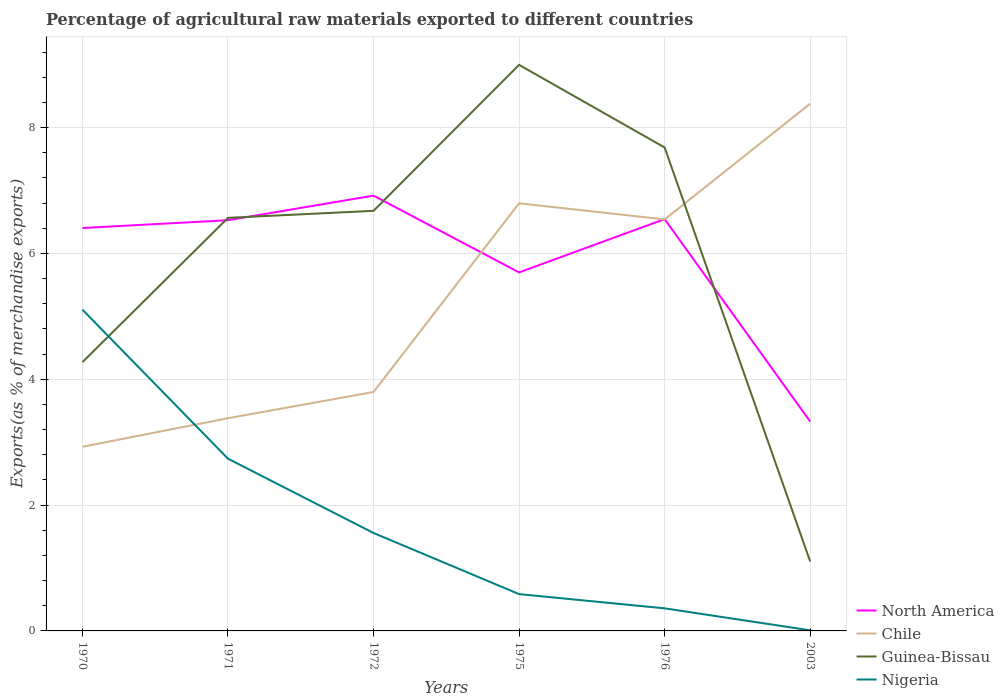Does the line corresponding to Guinea-Bissau intersect with the line corresponding to Nigeria?
Your answer should be very brief. Yes. Is the number of lines equal to the number of legend labels?
Keep it short and to the point. Yes. Across all years, what is the maximum percentage of exports to different countries in Chile?
Provide a succinct answer. 2.93. In which year was the percentage of exports to different countries in Nigeria maximum?
Give a very brief answer. 2003. What is the total percentage of exports to different countries in North America in the graph?
Provide a short and direct response. 3.59. What is the difference between the highest and the second highest percentage of exports to different countries in Nigeria?
Provide a short and direct response. 5.1. What is the difference between the highest and the lowest percentage of exports to different countries in Chile?
Offer a terse response. 3. Is the percentage of exports to different countries in Guinea-Bissau strictly greater than the percentage of exports to different countries in Chile over the years?
Keep it short and to the point. No. How many lines are there?
Your answer should be compact. 4. Are the values on the major ticks of Y-axis written in scientific E-notation?
Provide a short and direct response. No. Does the graph contain grids?
Offer a terse response. Yes. How many legend labels are there?
Ensure brevity in your answer.  4. What is the title of the graph?
Your answer should be compact. Percentage of agricultural raw materials exported to different countries. Does "Heavily indebted poor countries" appear as one of the legend labels in the graph?
Keep it short and to the point. No. What is the label or title of the Y-axis?
Ensure brevity in your answer.  Exports(as % of merchandise exports). What is the Exports(as % of merchandise exports) in North America in 1970?
Provide a short and direct response. 6.4. What is the Exports(as % of merchandise exports) of Chile in 1970?
Offer a terse response. 2.93. What is the Exports(as % of merchandise exports) of Guinea-Bissau in 1970?
Make the answer very short. 4.27. What is the Exports(as % of merchandise exports) in Nigeria in 1970?
Your response must be concise. 5.11. What is the Exports(as % of merchandise exports) of North America in 1971?
Your response must be concise. 6.53. What is the Exports(as % of merchandise exports) in Chile in 1971?
Make the answer very short. 3.38. What is the Exports(as % of merchandise exports) in Guinea-Bissau in 1971?
Your answer should be compact. 6.57. What is the Exports(as % of merchandise exports) in Nigeria in 1971?
Provide a succinct answer. 2.74. What is the Exports(as % of merchandise exports) of North America in 1972?
Provide a short and direct response. 6.92. What is the Exports(as % of merchandise exports) in Chile in 1972?
Make the answer very short. 3.8. What is the Exports(as % of merchandise exports) of Guinea-Bissau in 1972?
Your answer should be compact. 6.68. What is the Exports(as % of merchandise exports) in Nigeria in 1972?
Offer a very short reply. 1.56. What is the Exports(as % of merchandise exports) in North America in 1975?
Your answer should be compact. 5.7. What is the Exports(as % of merchandise exports) of Chile in 1975?
Your answer should be very brief. 6.8. What is the Exports(as % of merchandise exports) in Guinea-Bissau in 1975?
Make the answer very short. 9. What is the Exports(as % of merchandise exports) in Nigeria in 1975?
Ensure brevity in your answer.  0.59. What is the Exports(as % of merchandise exports) in North America in 1976?
Your response must be concise. 6.55. What is the Exports(as % of merchandise exports) in Chile in 1976?
Make the answer very short. 6.54. What is the Exports(as % of merchandise exports) in Guinea-Bissau in 1976?
Offer a very short reply. 7.68. What is the Exports(as % of merchandise exports) in Nigeria in 1976?
Make the answer very short. 0.36. What is the Exports(as % of merchandise exports) in North America in 2003?
Offer a very short reply. 3.33. What is the Exports(as % of merchandise exports) of Chile in 2003?
Provide a succinct answer. 8.38. What is the Exports(as % of merchandise exports) in Guinea-Bissau in 2003?
Your answer should be very brief. 1.1. What is the Exports(as % of merchandise exports) of Nigeria in 2003?
Give a very brief answer. 0.01. Across all years, what is the maximum Exports(as % of merchandise exports) of North America?
Ensure brevity in your answer.  6.92. Across all years, what is the maximum Exports(as % of merchandise exports) in Chile?
Offer a very short reply. 8.38. Across all years, what is the maximum Exports(as % of merchandise exports) of Guinea-Bissau?
Your answer should be very brief. 9. Across all years, what is the maximum Exports(as % of merchandise exports) in Nigeria?
Your response must be concise. 5.11. Across all years, what is the minimum Exports(as % of merchandise exports) of North America?
Offer a terse response. 3.33. Across all years, what is the minimum Exports(as % of merchandise exports) of Chile?
Your answer should be very brief. 2.93. Across all years, what is the minimum Exports(as % of merchandise exports) in Guinea-Bissau?
Your answer should be compact. 1.1. Across all years, what is the minimum Exports(as % of merchandise exports) of Nigeria?
Offer a very short reply. 0.01. What is the total Exports(as % of merchandise exports) of North America in the graph?
Your response must be concise. 35.43. What is the total Exports(as % of merchandise exports) in Chile in the graph?
Your response must be concise. 31.83. What is the total Exports(as % of merchandise exports) in Guinea-Bissau in the graph?
Provide a succinct answer. 35.3. What is the total Exports(as % of merchandise exports) in Nigeria in the graph?
Your answer should be compact. 10.36. What is the difference between the Exports(as % of merchandise exports) in North America in 1970 and that in 1971?
Provide a short and direct response. -0.12. What is the difference between the Exports(as % of merchandise exports) of Chile in 1970 and that in 1971?
Offer a terse response. -0.45. What is the difference between the Exports(as % of merchandise exports) of Guinea-Bissau in 1970 and that in 1971?
Keep it short and to the point. -2.29. What is the difference between the Exports(as % of merchandise exports) of Nigeria in 1970 and that in 1971?
Provide a succinct answer. 2.37. What is the difference between the Exports(as % of merchandise exports) of North America in 1970 and that in 1972?
Offer a terse response. -0.52. What is the difference between the Exports(as % of merchandise exports) in Chile in 1970 and that in 1972?
Give a very brief answer. -0.87. What is the difference between the Exports(as % of merchandise exports) in Guinea-Bissau in 1970 and that in 1972?
Your answer should be very brief. -2.41. What is the difference between the Exports(as % of merchandise exports) in Nigeria in 1970 and that in 1972?
Give a very brief answer. 3.55. What is the difference between the Exports(as % of merchandise exports) in North America in 1970 and that in 1975?
Provide a succinct answer. 0.71. What is the difference between the Exports(as % of merchandise exports) of Chile in 1970 and that in 1975?
Provide a succinct answer. -3.87. What is the difference between the Exports(as % of merchandise exports) in Guinea-Bissau in 1970 and that in 1975?
Keep it short and to the point. -4.73. What is the difference between the Exports(as % of merchandise exports) in Nigeria in 1970 and that in 1975?
Your answer should be very brief. 4.52. What is the difference between the Exports(as % of merchandise exports) in North America in 1970 and that in 1976?
Provide a short and direct response. -0.14. What is the difference between the Exports(as % of merchandise exports) in Chile in 1970 and that in 1976?
Your answer should be compact. -3.61. What is the difference between the Exports(as % of merchandise exports) of Guinea-Bissau in 1970 and that in 1976?
Your response must be concise. -3.41. What is the difference between the Exports(as % of merchandise exports) of Nigeria in 1970 and that in 1976?
Offer a terse response. 4.75. What is the difference between the Exports(as % of merchandise exports) in North America in 1970 and that in 2003?
Provide a short and direct response. 3.08. What is the difference between the Exports(as % of merchandise exports) of Chile in 1970 and that in 2003?
Your response must be concise. -5.45. What is the difference between the Exports(as % of merchandise exports) in Guinea-Bissau in 1970 and that in 2003?
Offer a terse response. 3.17. What is the difference between the Exports(as % of merchandise exports) in Nigeria in 1970 and that in 2003?
Ensure brevity in your answer.  5.1. What is the difference between the Exports(as % of merchandise exports) in North America in 1971 and that in 1972?
Give a very brief answer. -0.39. What is the difference between the Exports(as % of merchandise exports) of Chile in 1971 and that in 1972?
Provide a succinct answer. -0.42. What is the difference between the Exports(as % of merchandise exports) of Guinea-Bissau in 1971 and that in 1972?
Offer a terse response. -0.11. What is the difference between the Exports(as % of merchandise exports) of Nigeria in 1971 and that in 1972?
Ensure brevity in your answer.  1.18. What is the difference between the Exports(as % of merchandise exports) of North America in 1971 and that in 1975?
Offer a very short reply. 0.83. What is the difference between the Exports(as % of merchandise exports) in Chile in 1971 and that in 1975?
Offer a terse response. -3.42. What is the difference between the Exports(as % of merchandise exports) of Guinea-Bissau in 1971 and that in 1975?
Give a very brief answer. -2.43. What is the difference between the Exports(as % of merchandise exports) in Nigeria in 1971 and that in 1975?
Provide a succinct answer. 2.15. What is the difference between the Exports(as % of merchandise exports) of North America in 1971 and that in 1976?
Offer a very short reply. -0.02. What is the difference between the Exports(as % of merchandise exports) in Chile in 1971 and that in 1976?
Provide a succinct answer. -3.16. What is the difference between the Exports(as % of merchandise exports) of Guinea-Bissau in 1971 and that in 1976?
Ensure brevity in your answer.  -1.12. What is the difference between the Exports(as % of merchandise exports) in Nigeria in 1971 and that in 1976?
Ensure brevity in your answer.  2.38. What is the difference between the Exports(as % of merchandise exports) of Chile in 1971 and that in 2003?
Provide a succinct answer. -5. What is the difference between the Exports(as % of merchandise exports) in Guinea-Bissau in 1971 and that in 2003?
Your response must be concise. 5.46. What is the difference between the Exports(as % of merchandise exports) of Nigeria in 1971 and that in 2003?
Your response must be concise. 2.73. What is the difference between the Exports(as % of merchandise exports) of North America in 1972 and that in 1975?
Keep it short and to the point. 1.22. What is the difference between the Exports(as % of merchandise exports) of Chile in 1972 and that in 1975?
Ensure brevity in your answer.  -3. What is the difference between the Exports(as % of merchandise exports) in Guinea-Bissau in 1972 and that in 1975?
Give a very brief answer. -2.32. What is the difference between the Exports(as % of merchandise exports) in Nigeria in 1972 and that in 1975?
Offer a very short reply. 0.97. What is the difference between the Exports(as % of merchandise exports) of North America in 1972 and that in 1976?
Your answer should be very brief. 0.37. What is the difference between the Exports(as % of merchandise exports) of Chile in 1972 and that in 1976?
Offer a very short reply. -2.74. What is the difference between the Exports(as % of merchandise exports) of Guinea-Bissau in 1972 and that in 1976?
Provide a short and direct response. -1.01. What is the difference between the Exports(as % of merchandise exports) of Nigeria in 1972 and that in 1976?
Provide a short and direct response. 1.2. What is the difference between the Exports(as % of merchandise exports) in North America in 1972 and that in 2003?
Make the answer very short. 3.59. What is the difference between the Exports(as % of merchandise exports) of Chile in 1972 and that in 2003?
Give a very brief answer. -4.58. What is the difference between the Exports(as % of merchandise exports) of Guinea-Bissau in 1972 and that in 2003?
Your answer should be compact. 5.57. What is the difference between the Exports(as % of merchandise exports) of Nigeria in 1972 and that in 2003?
Offer a terse response. 1.55. What is the difference between the Exports(as % of merchandise exports) in North America in 1975 and that in 1976?
Your response must be concise. -0.85. What is the difference between the Exports(as % of merchandise exports) in Chile in 1975 and that in 1976?
Offer a very short reply. 0.26. What is the difference between the Exports(as % of merchandise exports) in Guinea-Bissau in 1975 and that in 1976?
Give a very brief answer. 1.31. What is the difference between the Exports(as % of merchandise exports) in Nigeria in 1975 and that in 1976?
Offer a terse response. 0.23. What is the difference between the Exports(as % of merchandise exports) of North America in 1975 and that in 2003?
Provide a succinct answer. 2.37. What is the difference between the Exports(as % of merchandise exports) in Chile in 1975 and that in 2003?
Offer a very short reply. -1.58. What is the difference between the Exports(as % of merchandise exports) of Guinea-Bissau in 1975 and that in 2003?
Your response must be concise. 7.89. What is the difference between the Exports(as % of merchandise exports) of Nigeria in 1975 and that in 2003?
Offer a very short reply. 0.58. What is the difference between the Exports(as % of merchandise exports) in North America in 1976 and that in 2003?
Your response must be concise. 3.22. What is the difference between the Exports(as % of merchandise exports) of Chile in 1976 and that in 2003?
Your answer should be compact. -1.84. What is the difference between the Exports(as % of merchandise exports) of Guinea-Bissau in 1976 and that in 2003?
Provide a succinct answer. 6.58. What is the difference between the Exports(as % of merchandise exports) in Nigeria in 1976 and that in 2003?
Make the answer very short. 0.35. What is the difference between the Exports(as % of merchandise exports) of North America in 1970 and the Exports(as % of merchandise exports) of Chile in 1971?
Keep it short and to the point. 3.02. What is the difference between the Exports(as % of merchandise exports) of North America in 1970 and the Exports(as % of merchandise exports) of Guinea-Bissau in 1971?
Your response must be concise. -0.16. What is the difference between the Exports(as % of merchandise exports) in North America in 1970 and the Exports(as % of merchandise exports) in Nigeria in 1971?
Provide a succinct answer. 3.67. What is the difference between the Exports(as % of merchandise exports) in Chile in 1970 and the Exports(as % of merchandise exports) in Guinea-Bissau in 1971?
Give a very brief answer. -3.64. What is the difference between the Exports(as % of merchandise exports) of Chile in 1970 and the Exports(as % of merchandise exports) of Nigeria in 1971?
Make the answer very short. 0.19. What is the difference between the Exports(as % of merchandise exports) of Guinea-Bissau in 1970 and the Exports(as % of merchandise exports) of Nigeria in 1971?
Offer a terse response. 1.53. What is the difference between the Exports(as % of merchandise exports) of North America in 1970 and the Exports(as % of merchandise exports) of Chile in 1972?
Offer a terse response. 2.61. What is the difference between the Exports(as % of merchandise exports) in North America in 1970 and the Exports(as % of merchandise exports) in Guinea-Bissau in 1972?
Give a very brief answer. -0.27. What is the difference between the Exports(as % of merchandise exports) in North America in 1970 and the Exports(as % of merchandise exports) in Nigeria in 1972?
Your response must be concise. 4.85. What is the difference between the Exports(as % of merchandise exports) of Chile in 1970 and the Exports(as % of merchandise exports) of Guinea-Bissau in 1972?
Make the answer very short. -3.75. What is the difference between the Exports(as % of merchandise exports) of Chile in 1970 and the Exports(as % of merchandise exports) of Nigeria in 1972?
Make the answer very short. 1.37. What is the difference between the Exports(as % of merchandise exports) of Guinea-Bissau in 1970 and the Exports(as % of merchandise exports) of Nigeria in 1972?
Give a very brief answer. 2.71. What is the difference between the Exports(as % of merchandise exports) in North America in 1970 and the Exports(as % of merchandise exports) in Chile in 1975?
Make the answer very short. -0.39. What is the difference between the Exports(as % of merchandise exports) in North America in 1970 and the Exports(as % of merchandise exports) in Guinea-Bissau in 1975?
Ensure brevity in your answer.  -2.59. What is the difference between the Exports(as % of merchandise exports) in North America in 1970 and the Exports(as % of merchandise exports) in Nigeria in 1975?
Provide a succinct answer. 5.82. What is the difference between the Exports(as % of merchandise exports) in Chile in 1970 and the Exports(as % of merchandise exports) in Guinea-Bissau in 1975?
Keep it short and to the point. -6.07. What is the difference between the Exports(as % of merchandise exports) in Chile in 1970 and the Exports(as % of merchandise exports) in Nigeria in 1975?
Your response must be concise. 2.34. What is the difference between the Exports(as % of merchandise exports) in Guinea-Bissau in 1970 and the Exports(as % of merchandise exports) in Nigeria in 1975?
Your response must be concise. 3.69. What is the difference between the Exports(as % of merchandise exports) of North America in 1970 and the Exports(as % of merchandise exports) of Chile in 1976?
Make the answer very short. -0.14. What is the difference between the Exports(as % of merchandise exports) of North America in 1970 and the Exports(as % of merchandise exports) of Guinea-Bissau in 1976?
Offer a very short reply. -1.28. What is the difference between the Exports(as % of merchandise exports) in North America in 1970 and the Exports(as % of merchandise exports) in Nigeria in 1976?
Your answer should be very brief. 6.05. What is the difference between the Exports(as % of merchandise exports) of Chile in 1970 and the Exports(as % of merchandise exports) of Guinea-Bissau in 1976?
Ensure brevity in your answer.  -4.76. What is the difference between the Exports(as % of merchandise exports) of Chile in 1970 and the Exports(as % of merchandise exports) of Nigeria in 1976?
Make the answer very short. 2.57. What is the difference between the Exports(as % of merchandise exports) of Guinea-Bissau in 1970 and the Exports(as % of merchandise exports) of Nigeria in 1976?
Offer a very short reply. 3.91. What is the difference between the Exports(as % of merchandise exports) of North America in 1970 and the Exports(as % of merchandise exports) of Chile in 2003?
Keep it short and to the point. -1.98. What is the difference between the Exports(as % of merchandise exports) of North America in 1970 and the Exports(as % of merchandise exports) of Guinea-Bissau in 2003?
Make the answer very short. 5.3. What is the difference between the Exports(as % of merchandise exports) in North America in 1970 and the Exports(as % of merchandise exports) in Nigeria in 2003?
Provide a short and direct response. 6.4. What is the difference between the Exports(as % of merchandise exports) of Chile in 1970 and the Exports(as % of merchandise exports) of Guinea-Bissau in 2003?
Offer a terse response. 1.82. What is the difference between the Exports(as % of merchandise exports) in Chile in 1970 and the Exports(as % of merchandise exports) in Nigeria in 2003?
Make the answer very short. 2.92. What is the difference between the Exports(as % of merchandise exports) of Guinea-Bissau in 1970 and the Exports(as % of merchandise exports) of Nigeria in 2003?
Your answer should be compact. 4.26. What is the difference between the Exports(as % of merchandise exports) of North America in 1971 and the Exports(as % of merchandise exports) of Chile in 1972?
Provide a short and direct response. 2.73. What is the difference between the Exports(as % of merchandise exports) of North America in 1971 and the Exports(as % of merchandise exports) of Guinea-Bissau in 1972?
Provide a succinct answer. -0.15. What is the difference between the Exports(as % of merchandise exports) of North America in 1971 and the Exports(as % of merchandise exports) of Nigeria in 1972?
Provide a succinct answer. 4.97. What is the difference between the Exports(as % of merchandise exports) in Chile in 1971 and the Exports(as % of merchandise exports) in Guinea-Bissau in 1972?
Give a very brief answer. -3.3. What is the difference between the Exports(as % of merchandise exports) in Chile in 1971 and the Exports(as % of merchandise exports) in Nigeria in 1972?
Provide a succinct answer. 1.82. What is the difference between the Exports(as % of merchandise exports) of Guinea-Bissau in 1971 and the Exports(as % of merchandise exports) of Nigeria in 1972?
Keep it short and to the point. 5.01. What is the difference between the Exports(as % of merchandise exports) of North America in 1971 and the Exports(as % of merchandise exports) of Chile in 1975?
Your answer should be compact. -0.27. What is the difference between the Exports(as % of merchandise exports) in North America in 1971 and the Exports(as % of merchandise exports) in Guinea-Bissau in 1975?
Keep it short and to the point. -2.47. What is the difference between the Exports(as % of merchandise exports) of North America in 1971 and the Exports(as % of merchandise exports) of Nigeria in 1975?
Provide a short and direct response. 5.94. What is the difference between the Exports(as % of merchandise exports) in Chile in 1971 and the Exports(as % of merchandise exports) in Guinea-Bissau in 1975?
Your response must be concise. -5.62. What is the difference between the Exports(as % of merchandise exports) of Chile in 1971 and the Exports(as % of merchandise exports) of Nigeria in 1975?
Your response must be concise. 2.8. What is the difference between the Exports(as % of merchandise exports) in Guinea-Bissau in 1971 and the Exports(as % of merchandise exports) in Nigeria in 1975?
Keep it short and to the point. 5.98. What is the difference between the Exports(as % of merchandise exports) in North America in 1971 and the Exports(as % of merchandise exports) in Chile in 1976?
Your answer should be compact. -0.01. What is the difference between the Exports(as % of merchandise exports) of North America in 1971 and the Exports(as % of merchandise exports) of Guinea-Bissau in 1976?
Offer a terse response. -1.16. What is the difference between the Exports(as % of merchandise exports) of North America in 1971 and the Exports(as % of merchandise exports) of Nigeria in 1976?
Your answer should be compact. 6.17. What is the difference between the Exports(as % of merchandise exports) of Chile in 1971 and the Exports(as % of merchandise exports) of Guinea-Bissau in 1976?
Your response must be concise. -4.3. What is the difference between the Exports(as % of merchandise exports) in Chile in 1971 and the Exports(as % of merchandise exports) in Nigeria in 1976?
Keep it short and to the point. 3.02. What is the difference between the Exports(as % of merchandise exports) of Guinea-Bissau in 1971 and the Exports(as % of merchandise exports) of Nigeria in 1976?
Make the answer very short. 6.21. What is the difference between the Exports(as % of merchandise exports) in North America in 1971 and the Exports(as % of merchandise exports) in Chile in 2003?
Your response must be concise. -1.85. What is the difference between the Exports(as % of merchandise exports) of North America in 1971 and the Exports(as % of merchandise exports) of Guinea-Bissau in 2003?
Provide a short and direct response. 5.42. What is the difference between the Exports(as % of merchandise exports) of North America in 1971 and the Exports(as % of merchandise exports) of Nigeria in 2003?
Your response must be concise. 6.52. What is the difference between the Exports(as % of merchandise exports) in Chile in 1971 and the Exports(as % of merchandise exports) in Guinea-Bissau in 2003?
Your response must be concise. 2.28. What is the difference between the Exports(as % of merchandise exports) in Chile in 1971 and the Exports(as % of merchandise exports) in Nigeria in 2003?
Keep it short and to the point. 3.37. What is the difference between the Exports(as % of merchandise exports) in Guinea-Bissau in 1971 and the Exports(as % of merchandise exports) in Nigeria in 2003?
Make the answer very short. 6.56. What is the difference between the Exports(as % of merchandise exports) in North America in 1972 and the Exports(as % of merchandise exports) in Chile in 1975?
Offer a very short reply. 0.12. What is the difference between the Exports(as % of merchandise exports) of North America in 1972 and the Exports(as % of merchandise exports) of Guinea-Bissau in 1975?
Your answer should be very brief. -2.08. What is the difference between the Exports(as % of merchandise exports) of North America in 1972 and the Exports(as % of merchandise exports) of Nigeria in 1975?
Your answer should be compact. 6.33. What is the difference between the Exports(as % of merchandise exports) in Chile in 1972 and the Exports(as % of merchandise exports) in Guinea-Bissau in 1975?
Your answer should be very brief. -5.2. What is the difference between the Exports(as % of merchandise exports) in Chile in 1972 and the Exports(as % of merchandise exports) in Nigeria in 1975?
Offer a terse response. 3.21. What is the difference between the Exports(as % of merchandise exports) of Guinea-Bissau in 1972 and the Exports(as % of merchandise exports) of Nigeria in 1975?
Offer a terse response. 6.09. What is the difference between the Exports(as % of merchandise exports) in North America in 1972 and the Exports(as % of merchandise exports) in Chile in 1976?
Offer a terse response. 0.38. What is the difference between the Exports(as % of merchandise exports) in North America in 1972 and the Exports(as % of merchandise exports) in Guinea-Bissau in 1976?
Make the answer very short. -0.77. What is the difference between the Exports(as % of merchandise exports) of North America in 1972 and the Exports(as % of merchandise exports) of Nigeria in 1976?
Offer a terse response. 6.56. What is the difference between the Exports(as % of merchandise exports) of Chile in 1972 and the Exports(as % of merchandise exports) of Guinea-Bissau in 1976?
Your answer should be very brief. -3.89. What is the difference between the Exports(as % of merchandise exports) of Chile in 1972 and the Exports(as % of merchandise exports) of Nigeria in 1976?
Offer a very short reply. 3.44. What is the difference between the Exports(as % of merchandise exports) in Guinea-Bissau in 1972 and the Exports(as % of merchandise exports) in Nigeria in 1976?
Keep it short and to the point. 6.32. What is the difference between the Exports(as % of merchandise exports) of North America in 1972 and the Exports(as % of merchandise exports) of Chile in 2003?
Provide a short and direct response. -1.46. What is the difference between the Exports(as % of merchandise exports) of North America in 1972 and the Exports(as % of merchandise exports) of Guinea-Bissau in 2003?
Ensure brevity in your answer.  5.82. What is the difference between the Exports(as % of merchandise exports) in North America in 1972 and the Exports(as % of merchandise exports) in Nigeria in 2003?
Ensure brevity in your answer.  6.91. What is the difference between the Exports(as % of merchandise exports) in Chile in 1972 and the Exports(as % of merchandise exports) in Guinea-Bissau in 2003?
Provide a succinct answer. 2.69. What is the difference between the Exports(as % of merchandise exports) of Chile in 1972 and the Exports(as % of merchandise exports) of Nigeria in 2003?
Keep it short and to the point. 3.79. What is the difference between the Exports(as % of merchandise exports) in Guinea-Bissau in 1972 and the Exports(as % of merchandise exports) in Nigeria in 2003?
Provide a succinct answer. 6.67. What is the difference between the Exports(as % of merchandise exports) in North America in 1975 and the Exports(as % of merchandise exports) in Chile in 1976?
Keep it short and to the point. -0.84. What is the difference between the Exports(as % of merchandise exports) of North America in 1975 and the Exports(as % of merchandise exports) of Guinea-Bissau in 1976?
Make the answer very short. -1.99. What is the difference between the Exports(as % of merchandise exports) of North America in 1975 and the Exports(as % of merchandise exports) of Nigeria in 1976?
Keep it short and to the point. 5.34. What is the difference between the Exports(as % of merchandise exports) of Chile in 1975 and the Exports(as % of merchandise exports) of Guinea-Bissau in 1976?
Make the answer very short. -0.89. What is the difference between the Exports(as % of merchandise exports) of Chile in 1975 and the Exports(as % of merchandise exports) of Nigeria in 1976?
Provide a short and direct response. 6.44. What is the difference between the Exports(as % of merchandise exports) in Guinea-Bissau in 1975 and the Exports(as % of merchandise exports) in Nigeria in 1976?
Your response must be concise. 8.64. What is the difference between the Exports(as % of merchandise exports) in North America in 1975 and the Exports(as % of merchandise exports) in Chile in 2003?
Your answer should be compact. -2.68. What is the difference between the Exports(as % of merchandise exports) of North America in 1975 and the Exports(as % of merchandise exports) of Guinea-Bissau in 2003?
Provide a short and direct response. 4.59. What is the difference between the Exports(as % of merchandise exports) in North America in 1975 and the Exports(as % of merchandise exports) in Nigeria in 2003?
Provide a succinct answer. 5.69. What is the difference between the Exports(as % of merchandise exports) in Chile in 1975 and the Exports(as % of merchandise exports) in Guinea-Bissau in 2003?
Offer a very short reply. 5.69. What is the difference between the Exports(as % of merchandise exports) of Chile in 1975 and the Exports(as % of merchandise exports) of Nigeria in 2003?
Your answer should be compact. 6.79. What is the difference between the Exports(as % of merchandise exports) of Guinea-Bissau in 1975 and the Exports(as % of merchandise exports) of Nigeria in 2003?
Keep it short and to the point. 8.99. What is the difference between the Exports(as % of merchandise exports) of North America in 1976 and the Exports(as % of merchandise exports) of Chile in 2003?
Your response must be concise. -1.83. What is the difference between the Exports(as % of merchandise exports) in North America in 1976 and the Exports(as % of merchandise exports) in Guinea-Bissau in 2003?
Make the answer very short. 5.44. What is the difference between the Exports(as % of merchandise exports) in North America in 1976 and the Exports(as % of merchandise exports) in Nigeria in 2003?
Offer a terse response. 6.54. What is the difference between the Exports(as % of merchandise exports) in Chile in 1976 and the Exports(as % of merchandise exports) in Guinea-Bissau in 2003?
Your answer should be very brief. 5.44. What is the difference between the Exports(as % of merchandise exports) in Chile in 1976 and the Exports(as % of merchandise exports) in Nigeria in 2003?
Give a very brief answer. 6.53. What is the difference between the Exports(as % of merchandise exports) of Guinea-Bissau in 1976 and the Exports(as % of merchandise exports) of Nigeria in 2003?
Your answer should be very brief. 7.68. What is the average Exports(as % of merchandise exports) in North America per year?
Offer a terse response. 5.9. What is the average Exports(as % of merchandise exports) in Chile per year?
Ensure brevity in your answer.  5.3. What is the average Exports(as % of merchandise exports) of Guinea-Bissau per year?
Make the answer very short. 5.88. What is the average Exports(as % of merchandise exports) in Nigeria per year?
Keep it short and to the point. 1.73. In the year 1970, what is the difference between the Exports(as % of merchandise exports) of North America and Exports(as % of merchandise exports) of Chile?
Keep it short and to the point. 3.48. In the year 1970, what is the difference between the Exports(as % of merchandise exports) of North America and Exports(as % of merchandise exports) of Guinea-Bissau?
Give a very brief answer. 2.13. In the year 1970, what is the difference between the Exports(as % of merchandise exports) of North America and Exports(as % of merchandise exports) of Nigeria?
Ensure brevity in your answer.  1.3. In the year 1970, what is the difference between the Exports(as % of merchandise exports) of Chile and Exports(as % of merchandise exports) of Guinea-Bissau?
Provide a succinct answer. -1.34. In the year 1970, what is the difference between the Exports(as % of merchandise exports) of Chile and Exports(as % of merchandise exports) of Nigeria?
Keep it short and to the point. -2.18. In the year 1970, what is the difference between the Exports(as % of merchandise exports) in Guinea-Bissau and Exports(as % of merchandise exports) in Nigeria?
Your answer should be compact. -0.83. In the year 1971, what is the difference between the Exports(as % of merchandise exports) of North America and Exports(as % of merchandise exports) of Chile?
Give a very brief answer. 3.15. In the year 1971, what is the difference between the Exports(as % of merchandise exports) in North America and Exports(as % of merchandise exports) in Guinea-Bissau?
Offer a terse response. -0.04. In the year 1971, what is the difference between the Exports(as % of merchandise exports) of North America and Exports(as % of merchandise exports) of Nigeria?
Make the answer very short. 3.79. In the year 1971, what is the difference between the Exports(as % of merchandise exports) of Chile and Exports(as % of merchandise exports) of Guinea-Bissau?
Provide a short and direct response. -3.19. In the year 1971, what is the difference between the Exports(as % of merchandise exports) of Chile and Exports(as % of merchandise exports) of Nigeria?
Provide a succinct answer. 0.64. In the year 1971, what is the difference between the Exports(as % of merchandise exports) in Guinea-Bissau and Exports(as % of merchandise exports) in Nigeria?
Keep it short and to the point. 3.83. In the year 1972, what is the difference between the Exports(as % of merchandise exports) of North America and Exports(as % of merchandise exports) of Chile?
Provide a short and direct response. 3.12. In the year 1972, what is the difference between the Exports(as % of merchandise exports) of North America and Exports(as % of merchandise exports) of Guinea-Bissau?
Keep it short and to the point. 0.24. In the year 1972, what is the difference between the Exports(as % of merchandise exports) of North America and Exports(as % of merchandise exports) of Nigeria?
Offer a very short reply. 5.36. In the year 1972, what is the difference between the Exports(as % of merchandise exports) in Chile and Exports(as % of merchandise exports) in Guinea-Bissau?
Make the answer very short. -2.88. In the year 1972, what is the difference between the Exports(as % of merchandise exports) in Chile and Exports(as % of merchandise exports) in Nigeria?
Provide a short and direct response. 2.24. In the year 1972, what is the difference between the Exports(as % of merchandise exports) in Guinea-Bissau and Exports(as % of merchandise exports) in Nigeria?
Make the answer very short. 5.12. In the year 1975, what is the difference between the Exports(as % of merchandise exports) in North America and Exports(as % of merchandise exports) in Chile?
Keep it short and to the point. -1.1. In the year 1975, what is the difference between the Exports(as % of merchandise exports) of North America and Exports(as % of merchandise exports) of Guinea-Bissau?
Your answer should be very brief. -3.3. In the year 1975, what is the difference between the Exports(as % of merchandise exports) in North America and Exports(as % of merchandise exports) in Nigeria?
Make the answer very short. 5.11. In the year 1975, what is the difference between the Exports(as % of merchandise exports) in Chile and Exports(as % of merchandise exports) in Guinea-Bissau?
Your answer should be compact. -2.2. In the year 1975, what is the difference between the Exports(as % of merchandise exports) in Chile and Exports(as % of merchandise exports) in Nigeria?
Offer a terse response. 6.21. In the year 1975, what is the difference between the Exports(as % of merchandise exports) in Guinea-Bissau and Exports(as % of merchandise exports) in Nigeria?
Offer a terse response. 8.41. In the year 1976, what is the difference between the Exports(as % of merchandise exports) of North America and Exports(as % of merchandise exports) of Chile?
Offer a terse response. 0. In the year 1976, what is the difference between the Exports(as % of merchandise exports) of North America and Exports(as % of merchandise exports) of Guinea-Bissau?
Make the answer very short. -1.14. In the year 1976, what is the difference between the Exports(as % of merchandise exports) of North America and Exports(as % of merchandise exports) of Nigeria?
Give a very brief answer. 6.19. In the year 1976, what is the difference between the Exports(as % of merchandise exports) of Chile and Exports(as % of merchandise exports) of Guinea-Bissau?
Your answer should be very brief. -1.14. In the year 1976, what is the difference between the Exports(as % of merchandise exports) in Chile and Exports(as % of merchandise exports) in Nigeria?
Offer a terse response. 6.18. In the year 1976, what is the difference between the Exports(as % of merchandise exports) in Guinea-Bissau and Exports(as % of merchandise exports) in Nigeria?
Ensure brevity in your answer.  7.33. In the year 2003, what is the difference between the Exports(as % of merchandise exports) of North America and Exports(as % of merchandise exports) of Chile?
Offer a very short reply. -5.05. In the year 2003, what is the difference between the Exports(as % of merchandise exports) in North America and Exports(as % of merchandise exports) in Guinea-Bissau?
Provide a short and direct response. 2.22. In the year 2003, what is the difference between the Exports(as % of merchandise exports) in North America and Exports(as % of merchandise exports) in Nigeria?
Give a very brief answer. 3.32. In the year 2003, what is the difference between the Exports(as % of merchandise exports) of Chile and Exports(as % of merchandise exports) of Guinea-Bissau?
Offer a very short reply. 7.28. In the year 2003, what is the difference between the Exports(as % of merchandise exports) of Chile and Exports(as % of merchandise exports) of Nigeria?
Ensure brevity in your answer.  8.37. In the year 2003, what is the difference between the Exports(as % of merchandise exports) of Guinea-Bissau and Exports(as % of merchandise exports) of Nigeria?
Ensure brevity in your answer.  1.09. What is the ratio of the Exports(as % of merchandise exports) in Chile in 1970 to that in 1971?
Your response must be concise. 0.87. What is the ratio of the Exports(as % of merchandise exports) of Guinea-Bissau in 1970 to that in 1971?
Offer a very short reply. 0.65. What is the ratio of the Exports(as % of merchandise exports) of Nigeria in 1970 to that in 1971?
Your response must be concise. 1.87. What is the ratio of the Exports(as % of merchandise exports) in North America in 1970 to that in 1972?
Make the answer very short. 0.93. What is the ratio of the Exports(as % of merchandise exports) in Chile in 1970 to that in 1972?
Your answer should be very brief. 0.77. What is the ratio of the Exports(as % of merchandise exports) in Guinea-Bissau in 1970 to that in 1972?
Ensure brevity in your answer.  0.64. What is the ratio of the Exports(as % of merchandise exports) of Nigeria in 1970 to that in 1972?
Make the answer very short. 3.28. What is the ratio of the Exports(as % of merchandise exports) in North America in 1970 to that in 1975?
Your answer should be compact. 1.12. What is the ratio of the Exports(as % of merchandise exports) of Chile in 1970 to that in 1975?
Make the answer very short. 0.43. What is the ratio of the Exports(as % of merchandise exports) in Guinea-Bissau in 1970 to that in 1975?
Ensure brevity in your answer.  0.47. What is the ratio of the Exports(as % of merchandise exports) of Nigeria in 1970 to that in 1975?
Give a very brief answer. 8.73. What is the ratio of the Exports(as % of merchandise exports) of North America in 1970 to that in 1976?
Keep it short and to the point. 0.98. What is the ratio of the Exports(as % of merchandise exports) in Chile in 1970 to that in 1976?
Make the answer very short. 0.45. What is the ratio of the Exports(as % of merchandise exports) of Guinea-Bissau in 1970 to that in 1976?
Your answer should be very brief. 0.56. What is the ratio of the Exports(as % of merchandise exports) of Nigeria in 1970 to that in 1976?
Offer a very short reply. 14.23. What is the ratio of the Exports(as % of merchandise exports) of North America in 1970 to that in 2003?
Your answer should be very brief. 1.92. What is the ratio of the Exports(as % of merchandise exports) in Chile in 1970 to that in 2003?
Offer a very short reply. 0.35. What is the ratio of the Exports(as % of merchandise exports) in Guinea-Bissau in 1970 to that in 2003?
Make the answer very short. 3.87. What is the ratio of the Exports(as % of merchandise exports) in Nigeria in 1970 to that in 2003?
Your answer should be compact. 551.34. What is the ratio of the Exports(as % of merchandise exports) in North America in 1971 to that in 1972?
Provide a short and direct response. 0.94. What is the ratio of the Exports(as % of merchandise exports) in Chile in 1971 to that in 1972?
Provide a succinct answer. 0.89. What is the ratio of the Exports(as % of merchandise exports) of Guinea-Bissau in 1971 to that in 1972?
Provide a succinct answer. 0.98. What is the ratio of the Exports(as % of merchandise exports) of Nigeria in 1971 to that in 1972?
Your response must be concise. 1.76. What is the ratio of the Exports(as % of merchandise exports) of North America in 1971 to that in 1975?
Your answer should be very brief. 1.15. What is the ratio of the Exports(as % of merchandise exports) of Chile in 1971 to that in 1975?
Your response must be concise. 0.5. What is the ratio of the Exports(as % of merchandise exports) in Guinea-Bissau in 1971 to that in 1975?
Keep it short and to the point. 0.73. What is the ratio of the Exports(as % of merchandise exports) in Nigeria in 1971 to that in 1975?
Your response must be concise. 4.68. What is the ratio of the Exports(as % of merchandise exports) of North America in 1971 to that in 1976?
Offer a terse response. 1. What is the ratio of the Exports(as % of merchandise exports) of Chile in 1971 to that in 1976?
Your answer should be compact. 0.52. What is the ratio of the Exports(as % of merchandise exports) of Guinea-Bissau in 1971 to that in 1976?
Your answer should be very brief. 0.85. What is the ratio of the Exports(as % of merchandise exports) in Nigeria in 1971 to that in 1976?
Give a very brief answer. 7.63. What is the ratio of the Exports(as % of merchandise exports) in North America in 1971 to that in 2003?
Give a very brief answer. 1.96. What is the ratio of the Exports(as % of merchandise exports) of Chile in 1971 to that in 2003?
Your answer should be very brief. 0.4. What is the ratio of the Exports(as % of merchandise exports) in Guinea-Bissau in 1971 to that in 2003?
Make the answer very short. 5.95. What is the ratio of the Exports(as % of merchandise exports) of Nigeria in 1971 to that in 2003?
Ensure brevity in your answer.  295.58. What is the ratio of the Exports(as % of merchandise exports) in North America in 1972 to that in 1975?
Offer a terse response. 1.21. What is the ratio of the Exports(as % of merchandise exports) in Chile in 1972 to that in 1975?
Provide a short and direct response. 0.56. What is the ratio of the Exports(as % of merchandise exports) of Guinea-Bissau in 1972 to that in 1975?
Keep it short and to the point. 0.74. What is the ratio of the Exports(as % of merchandise exports) in Nigeria in 1972 to that in 1975?
Keep it short and to the point. 2.66. What is the ratio of the Exports(as % of merchandise exports) of North America in 1972 to that in 1976?
Make the answer very short. 1.06. What is the ratio of the Exports(as % of merchandise exports) in Chile in 1972 to that in 1976?
Keep it short and to the point. 0.58. What is the ratio of the Exports(as % of merchandise exports) in Guinea-Bissau in 1972 to that in 1976?
Offer a terse response. 0.87. What is the ratio of the Exports(as % of merchandise exports) of Nigeria in 1972 to that in 1976?
Keep it short and to the point. 4.34. What is the ratio of the Exports(as % of merchandise exports) in North America in 1972 to that in 2003?
Your answer should be very brief. 2.08. What is the ratio of the Exports(as % of merchandise exports) in Chile in 1972 to that in 2003?
Ensure brevity in your answer.  0.45. What is the ratio of the Exports(as % of merchandise exports) of Guinea-Bissau in 1972 to that in 2003?
Your response must be concise. 6.05. What is the ratio of the Exports(as % of merchandise exports) in Nigeria in 1972 to that in 2003?
Offer a terse response. 168.11. What is the ratio of the Exports(as % of merchandise exports) in North America in 1975 to that in 1976?
Your answer should be very brief. 0.87. What is the ratio of the Exports(as % of merchandise exports) of Chile in 1975 to that in 1976?
Ensure brevity in your answer.  1.04. What is the ratio of the Exports(as % of merchandise exports) in Guinea-Bissau in 1975 to that in 1976?
Offer a very short reply. 1.17. What is the ratio of the Exports(as % of merchandise exports) in Nigeria in 1975 to that in 1976?
Your answer should be very brief. 1.63. What is the ratio of the Exports(as % of merchandise exports) in North America in 1975 to that in 2003?
Your answer should be compact. 1.71. What is the ratio of the Exports(as % of merchandise exports) in Chile in 1975 to that in 2003?
Your answer should be very brief. 0.81. What is the ratio of the Exports(as % of merchandise exports) in Guinea-Bissau in 1975 to that in 2003?
Your answer should be compact. 8.15. What is the ratio of the Exports(as % of merchandise exports) in Nigeria in 1975 to that in 2003?
Ensure brevity in your answer.  63.19. What is the ratio of the Exports(as % of merchandise exports) in North America in 1976 to that in 2003?
Offer a terse response. 1.97. What is the ratio of the Exports(as % of merchandise exports) of Chile in 1976 to that in 2003?
Your answer should be very brief. 0.78. What is the ratio of the Exports(as % of merchandise exports) in Guinea-Bissau in 1976 to that in 2003?
Provide a short and direct response. 6.96. What is the ratio of the Exports(as % of merchandise exports) in Nigeria in 1976 to that in 2003?
Provide a succinct answer. 38.74. What is the difference between the highest and the second highest Exports(as % of merchandise exports) of North America?
Provide a short and direct response. 0.37. What is the difference between the highest and the second highest Exports(as % of merchandise exports) in Chile?
Provide a succinct answer. 1.58. What is the difference between the highest and the second highest Exports(as % of merchandise exports) in Guinea-Bissau?
Offer a very short reply. 1.31. What is the difference between the highest and the second highest Exports(as % of merchandise exports) in Nigeria?
Give a very brief answer. 2.37. What is the difference between the highest and the lowest Exports(as % of merchandise exports) of North America?
Offer a terse response. 3.59. What is the difference between the highest and the lowest Exports(as % of merchandise exports) of Chile?
Your response must be concise. 5.45. What is the difference between the highest and the lowest Exports(as % of merchandise exports) in Guinea-Bissau?
Your answer should be very brief. 7.89. What is the difference between the highest and the lowest Exports(as % of merchandise exports) of Nigeria?
Keep it short and to the point. 5.1. 